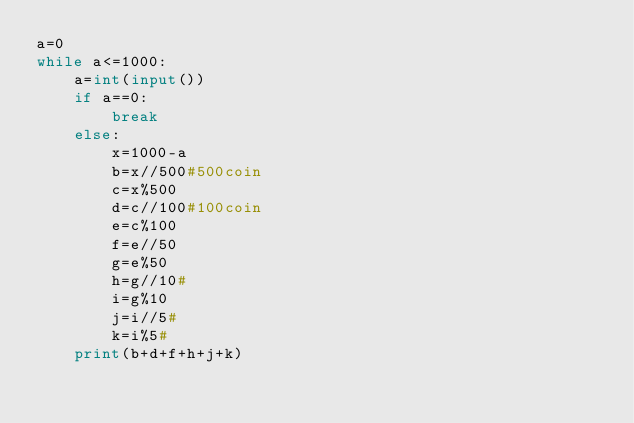<code> <loc_0><loc_0><loc_500><loc_500><_Python_>a=0
while a<=1000:
    a=int(input())
    if a==0:
        break
    else:
        x=1000-a
        b=x//500#500coin
        c=x%500
        d=c//100#100coin
        e=c%100
        f=e//50
        g=e%50
        h=g//10#
        i=g%10
        j=i//5#
        k=i%5#
    print(b+d+f+h+j+k)    
</code> 